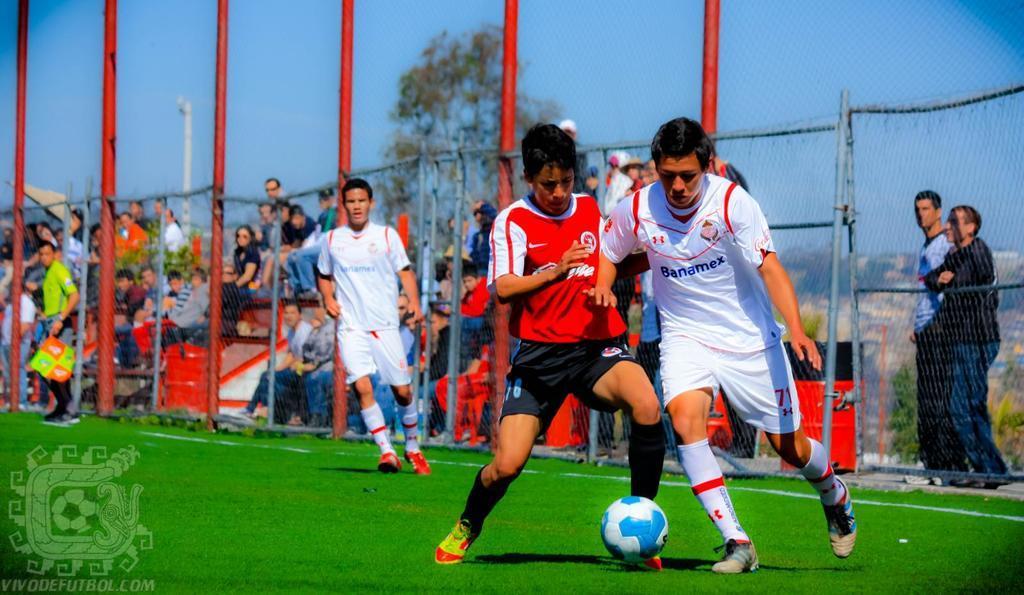Describe this image in one or two sentences. In this picture we can see three men running behind the ball on ground and here person is standing holding flag in his hands and in background we can see fence, people sitting on steps, trees, pipe, sky. 